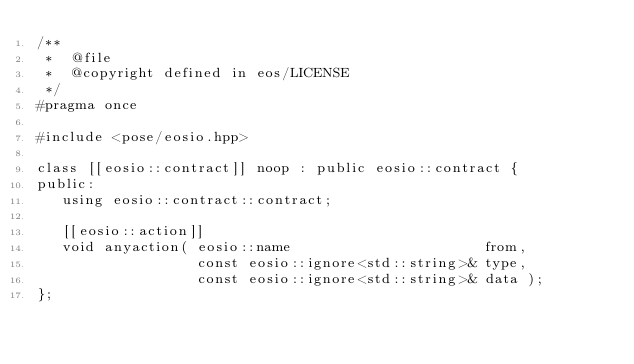Convert code to text. <code><loc_0><loc_0><loc_500><loc_500><_C++_>/**
 *  @file
 *  @copyright defined in eos/LICENSE
 */
#pragma once

#include <pose/eosio.hpp>

class [[eosio::contract]] noop : public eosio::contract {
public:
   using eosio::contract::contract;

   [[eosio::action]]
   void anyaction( eosio::name                       from,
                   const eosio::ignore<std::string>& type,
                   const eosio::ignore<std::string>& data );
};
</code> 